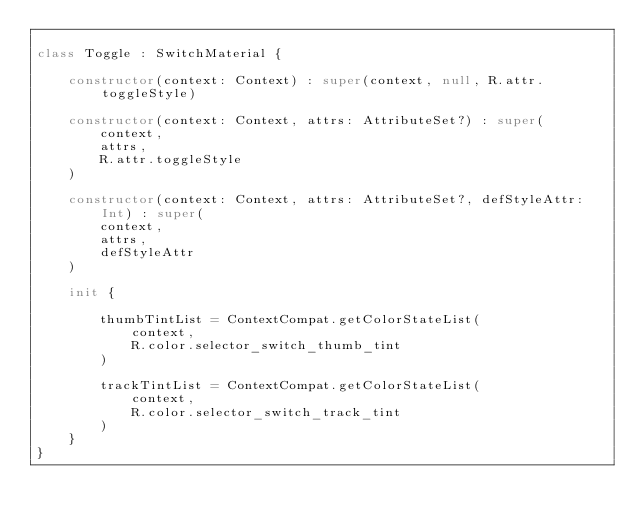<code> <loc_0><loc_0><loc_500><loc_500><_Kotlin_>
class Toggle : SwitchMaterial {

    constructor(context: Context) : super(context, null, R.attr.toggleStyle)

    constructor(context: Context, attrs: AttributeSet?) : super(
        context,
        attrs,
        R.attr.toggleStyle
    )

    constructor(context: Context, attrs: AttributeSet?, defStyleAttr: Int) : super(
        context,
        attrs,
        defStyleAttr
    )

    init {

        thumbTintList = ContextCompat.getColorStateList(
            context,
            R.color.selector_switch_thumb_tint
        )

        trackTintList = ContextCompat.getColorStateList(
            context,
            R.color.selector_switch_track_tint
        )
    }
}</code> 